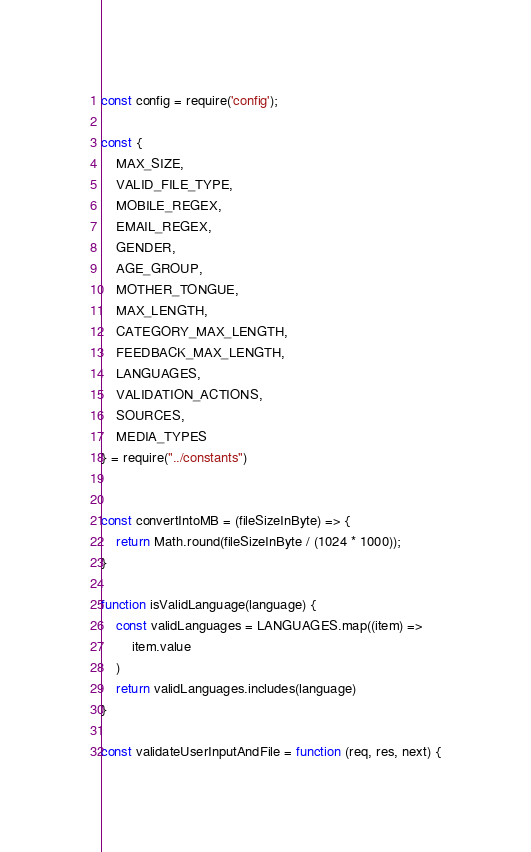Convert code to text. <code><loc_0><loc_0><loc_500><loc_500><_JavaScript_>const config = require('config');

const {
    MAX_SIZE,
    VALID_FILE_TYPE,
    MOBILE_REGEX,
    EMAIL_REGEX,
    GENDER,
    AGE_GROUP,
    MOTHER_TONGUE,
    MAX_LENGTH,
    CATEGORY_MAX_LENGTH,
    FEEDBACK_MAX_LENGTH,
    LANGUAGES,
    VALIDATION_ACTIONS,
    SOURCES,
    MEDIA_TYPES
} = require("../constants")


const convertIntoMB = (fileSizeInByte) => {
    return Math.round(fileSizeInByte / (1024 * 1000));
}

function isValidLanguage(language) {
    const validLanguages = LANGUAGES.map((item) =>
        item.value
    )
    return validLanguages.includes(language)
}

const validateUserInputAndFile = function (req, res, next) {</code> 